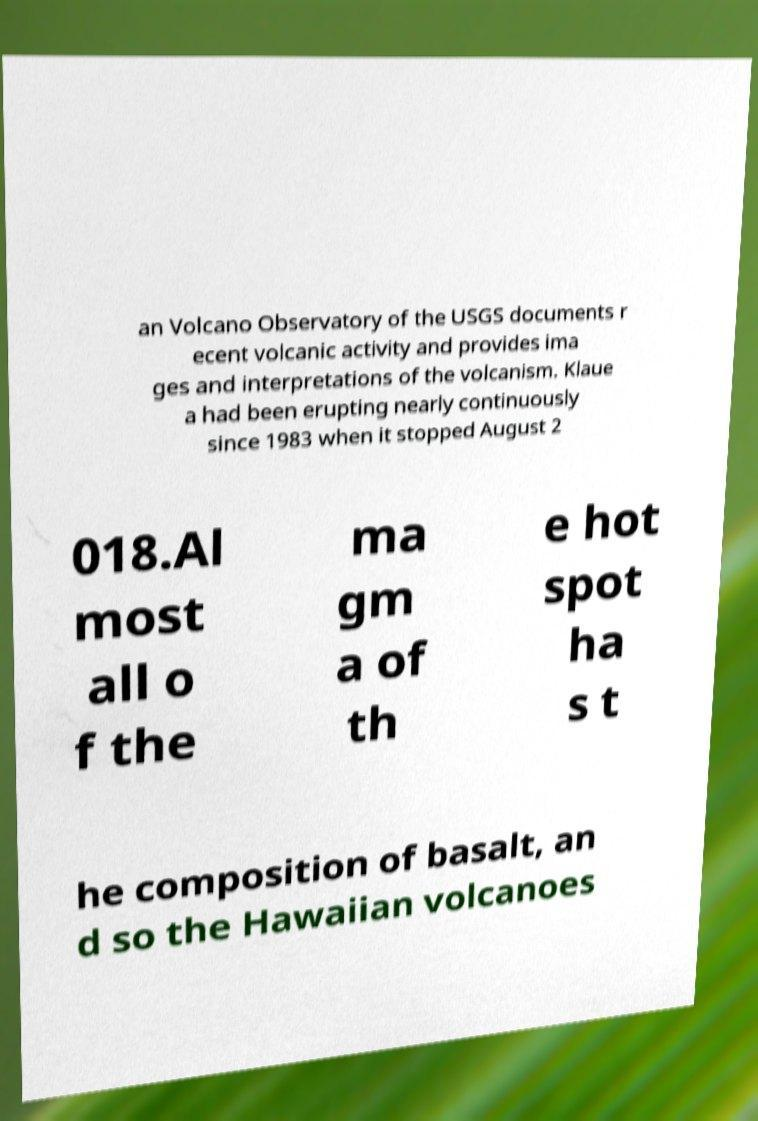Please identify and transcribe the text found in this image. an Volcano Observatory of the USGS documents r ecent volcanic activity and provides ima ges and interpretations of the volcanism. Klaue a had been erupting nearly continuously since 1983 when it stopped August 2 018.Al most all o f the ma gm a of th e hot spot ha s t he composition of basalt, an d so the Hawaiian volcanoes 